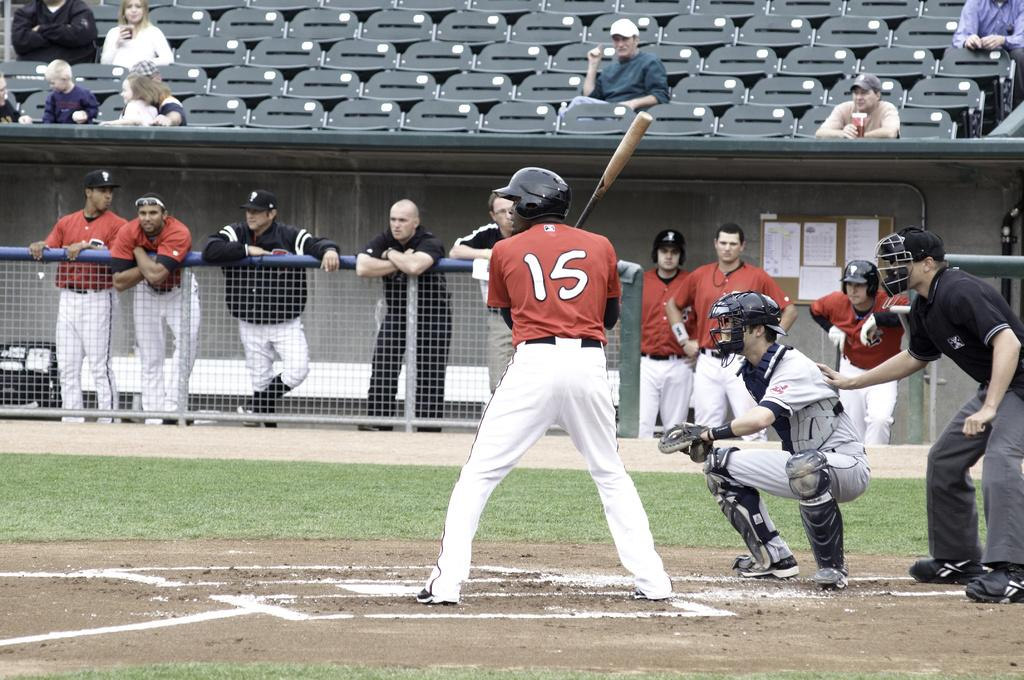<image>
Summarize the visual content of the image. Number 15 is in the batters box and is ready to hit. 